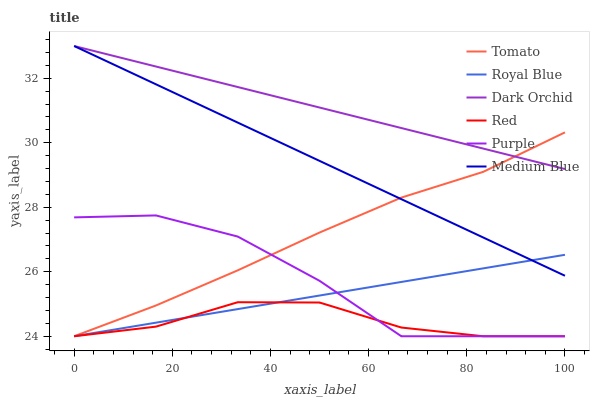Does Red have the minimum area under the curve?
Answer yes or no. Yes. Does Dark Orchid have the maximum area under the curve?
Answer yes or no. Yes. Does Purple have the minimum area under the curve?
Answer yes or no. No. Does Purple have the maximum area under the curve?
Answer yes or no. No. Is Medium Blue the smoothest?
Answer yes or no. Yes. Is Purple the roughest?
Answer yes or no. Yes. Is Purple the smoothest?
Answer yes or no. No. Is Medium Blue the roughest?
Answer yes or no. No. Does Tomato have the lowest value?
Answer yes or no. Yes. Does Medium Blue have the lowest value?
Answer yes or no. No. Does Dark Orchid have the highest value?
Answer yes or no. Yes. Does Purple have the highest value?
Answer yes or no. No. Is Red less than Dark Orchid?
Answer yes or no. Yes. Is Dark Orchid greater than Purple?
Answer yes or no. Yes. Does Dark Orchid intersect Tomato?
Answer yes or no. Yes. Is Dark Orchid less than Tomato?
Answer yes or no. No. Is Dark Orchid greater than Tomato?
Answer yes or no. No. Does Red intersect Dark Orchid?
Answer yes or no. No. 